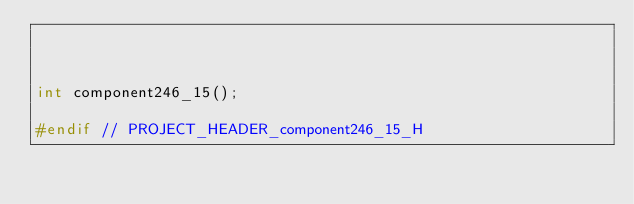<code> <loc_0><loc_0><loc_500><loc_500><_C_>


int component246_15();

#endif // PROJECT_HEADER_component246_15_H</code> 